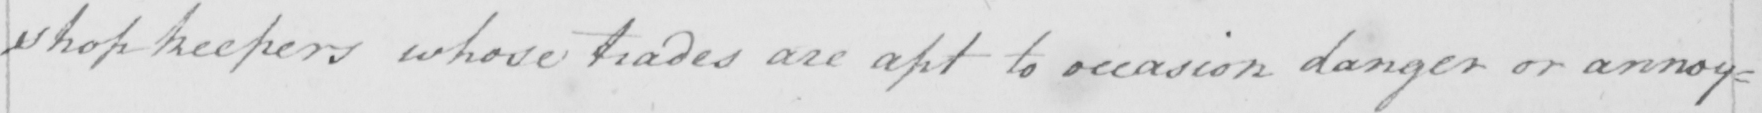What text is written in this handwritten line? shopkeepers whose trades are apt to occasion danger or annoy= 